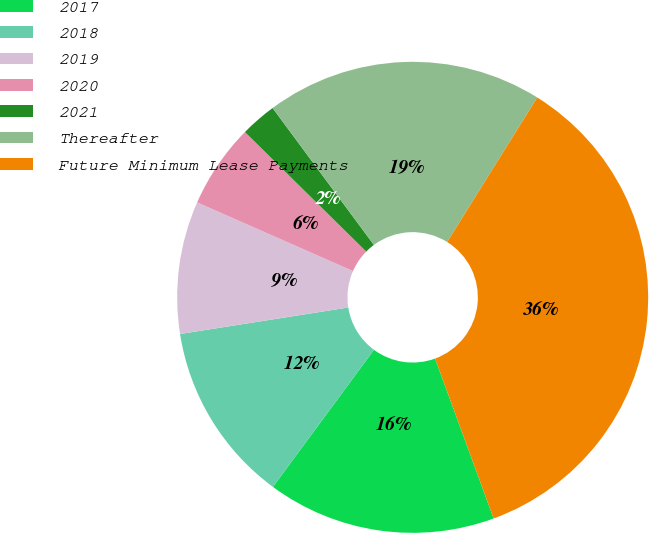Convert chart to OTSL. <chart><loc_0><loc_0><loc_500><loc_500><pie_chart><fcel>2017<fcel>2018<fcel>2019<fcel>2020<fcel>2021<fcel>Thereafter<fcel>Future Minimum Lease Payments<nl><fcel>15.7%<fcel>12.4%<fcel>9.09%<fcel>5.78%<fcel>2.48%<fcel>19.01%<fcel>35.54%<nl></chart> 